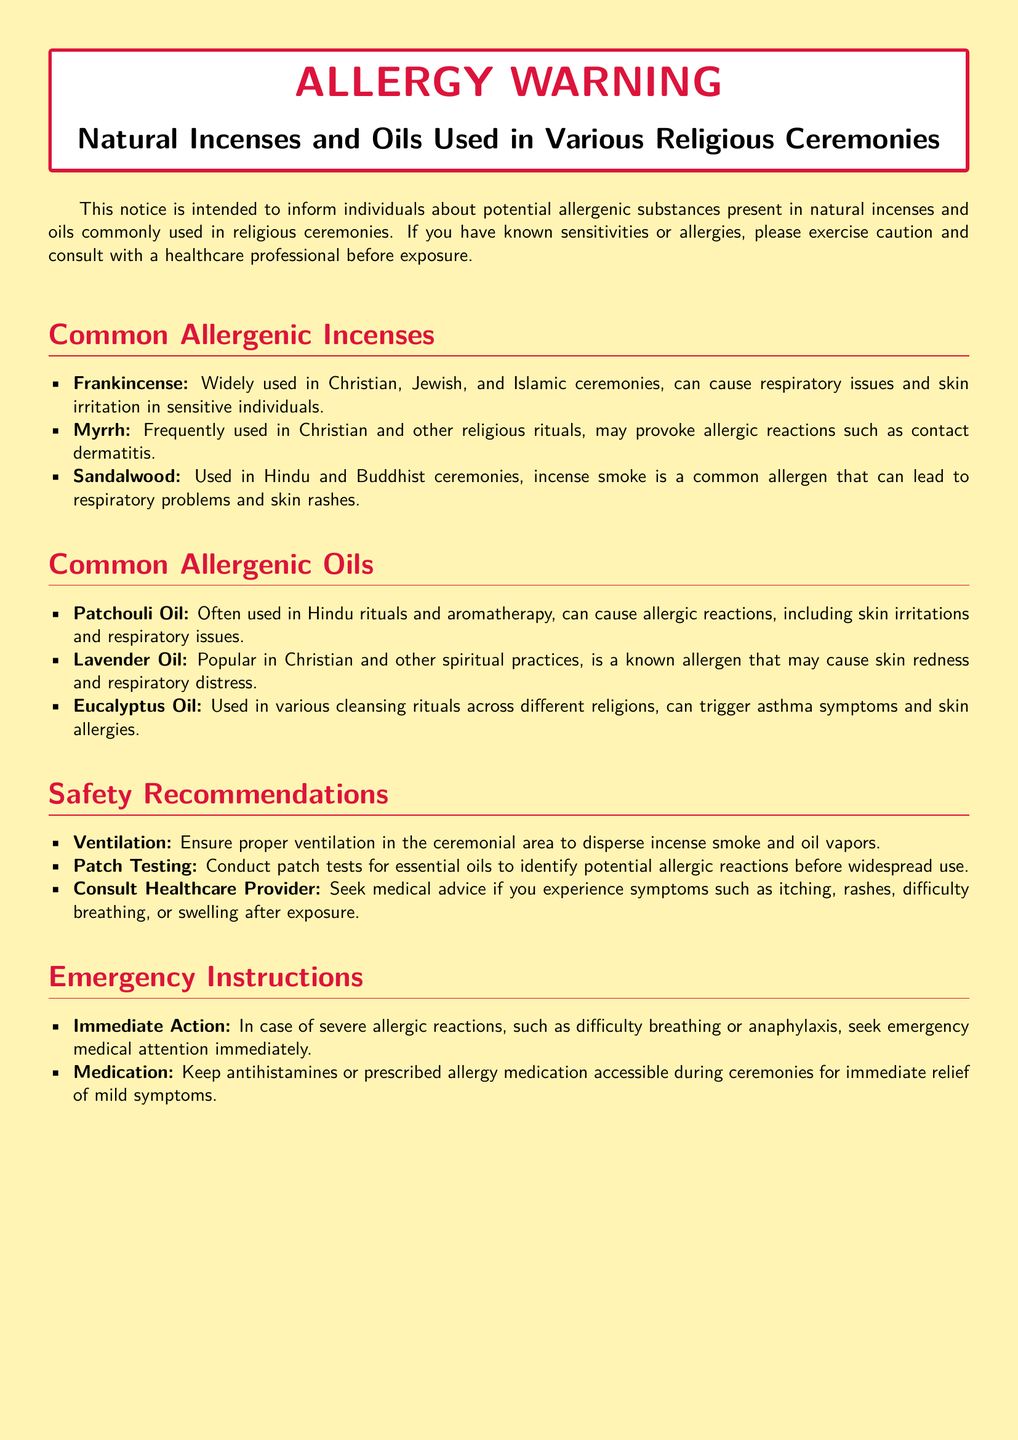What is the title of the document? The title of the document is stated prominently at the top in large print.
Answer: ALLERGY WARNING What are the common allergenic incenses listed? The document specifically lists three common allergenic incenses with brief descriptions.
Answer: Frankincense, Myrrh, Sandalwood What should be ensured in the ceremonial area according to the safety recommendations? According to the safety recommendations, proper ventilation should be ensured in the ceremonial area to disperse harmful substances.
Answer: Proper ventilation Which oil is known for causing skin redness? The document provides a specific allergy related to one of the oils mentioned.
Answer: Lavender Oil What is the immediate action to take in case of severe allergic reactions? The document specifies the actions to take during an emergency related to allergic reactions.
Answer: Seek emergency medical attention How many common allergenic oils are mentioned? The document lists a specific number of common allergenic oils in a section.
Answer: Three 